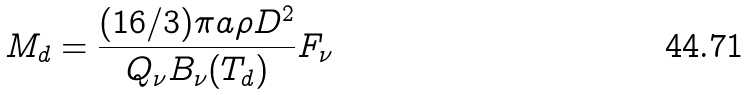Convert formula to latex. <formula><loc_0><loc_0><loc_500><loc_500>M _ { d } = \frac { ( 1 6 / 3 ) \pi a \rho D ^ { 2 } } { Q _ { \nu } B _ { \nu } ( T _ { d } ) } F _ { \nu }</formula> 